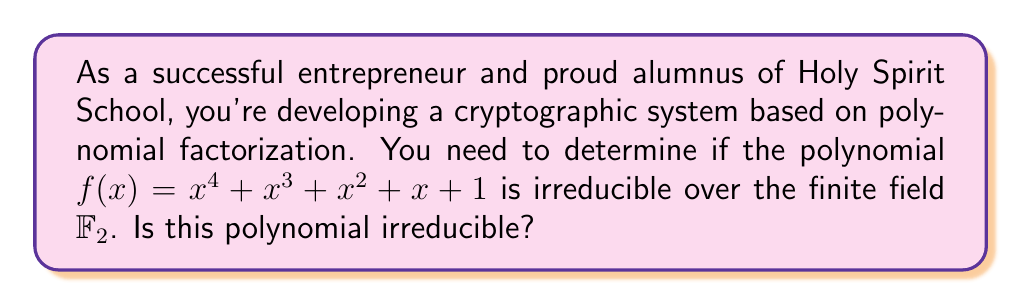Show me your answer to this math problem. To determine if the polynomial $f(x) = x^4 + x^3 + x^2 + x + 1$ is irreducible over $\mathbb{F}_2$, we can follow these steps:

1) First, note that $\mathbb{F}_2$ is the field with two elements, 0 and 1.

2) A polynomial of degree 4 over $\mathbb{F}_2$ is irreducible if and only if:
   a) It has no roots in $\mathbb{F}_2$
   b) It's not divisible by any irreducible polynomial of degree 2 over $\mathbb{F}_2$

3) Check for roots in $\mathbb{F}_2$:
   $f(0) = 0^4 + 0^3 + 0^2 + 0 + 1 = 1 \neq 0$
   $f(1) = 1^4 + 1^3 + 1^2 + 1 + 1 = 1 \neq 0$
   So, $f(x)$ has no roots in $\mathbb{F}_2$.

4) The only irreducible polynomial of degree 2 over $\mathbb{F}_2$ is $x^2 + x + 1$.

5) Divide $f(x)$ by $x^2 + x + 1$:
   
   $$\begin{array}{r}
   x^2 + x + 1 \enclose{longdiv}{x^4 + x^3 + x^2 + x + 1} \\
   \underline{x^4 + x^3 + x^2} \\
   x^3 + x + 1 \\
   \underline{x^3 + x^2 + x} \\
   x^2 + 1 \\
   \underline{x^2 + x + 1} \\
   x
   \end{array}$$

   The division leaves a remainder of $x$, so $f(x)$ is not divisible by $x^2 + x + 1$.

6) Since $f(x)$ has no roots in $\mathbb{F}_2$ and is not divisible by the only irreducible polynomial of degree 2 over $\mathbb{F}_2$, we can conclude that $f(x)$ is irreducible over $\mathbb{F}_2$.
Answer: Yes, the polynomial $f(x) = x^4 + x^3 + x^2 + x + 1$ is irreducible over $\mathbb{F}_2$. 